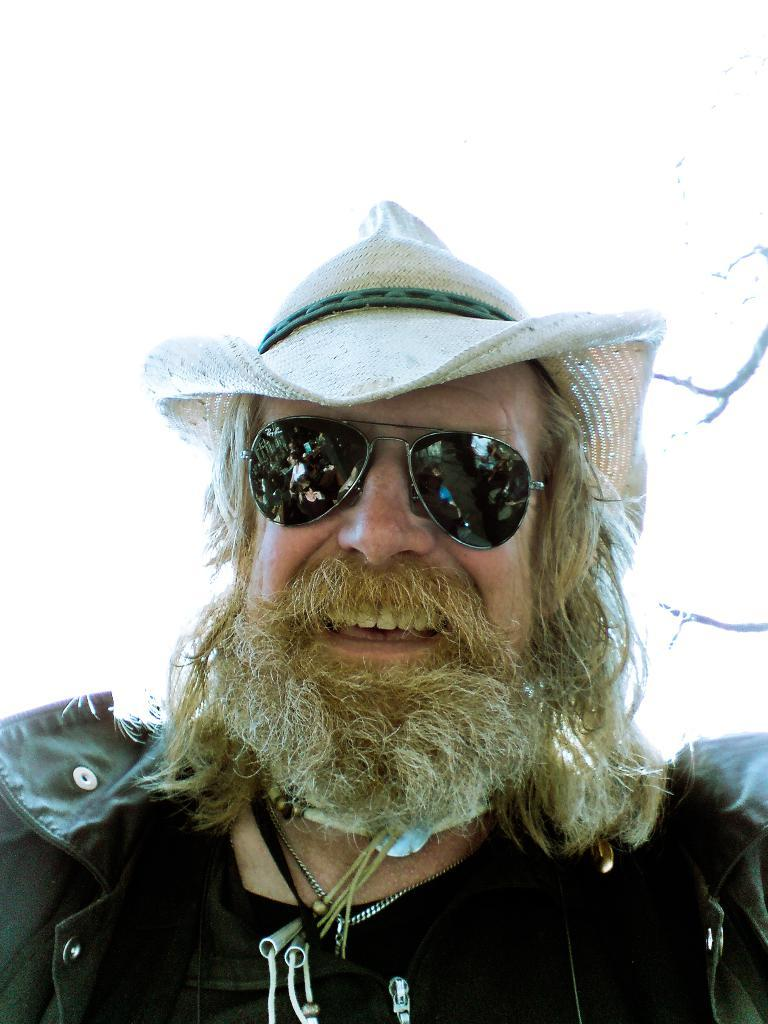Who is present in the image? There is a man in the image. What is the man wearing on his head? The man is wearing a hat. What type of eyewear is the man wearing? The man is wearing glasses. What expression does the man have in the image? The man is smiling. How many units of footwear can be seen in the image? There is no footwear visible in the image, as the focus is on the man and his attire. 